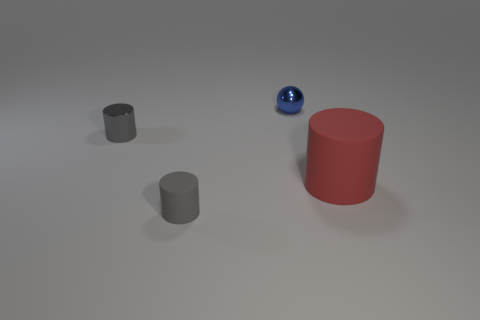Is there any other thing that is the same size as the red rubber cylinder?
Offer a very short reply. No. There is a tiny blue object behind the rubber object right of the small ball; what number of matte cylinders are right of it?
Offer a terse response. 1. Does the metallic cylinder have the same color as the cylinder that is in front of the red matte cylinder?
Your answer should be very brief. Yes. The matte object that is the same color as the tiny shiny cylinder is what shape?
Offer a very short reply. Cylinder. What is the material of the cylinder that is behind the red matte object behind the rubber object that is left of the tiny metallic sphere?
Give a very brief answer. Metal. Is the shape of the tiny metallic thing in front of the blue shiny sphere the same as  the tiny blue object?
Offer a terse response. No. What material is the cylinder in front of the red rubber object?
Your response must be concise. Rubber. How many metallic objects are either big red blocks or big cylinders?
Provide a succinct answer. 0. Is there another blue sphere of the same size as the shiny ball?
Make the answer very short. No. Are there more blue objects behind the big cylinder than big gray matte cylinders?
Ensure brevity in your answer.  Yes. 